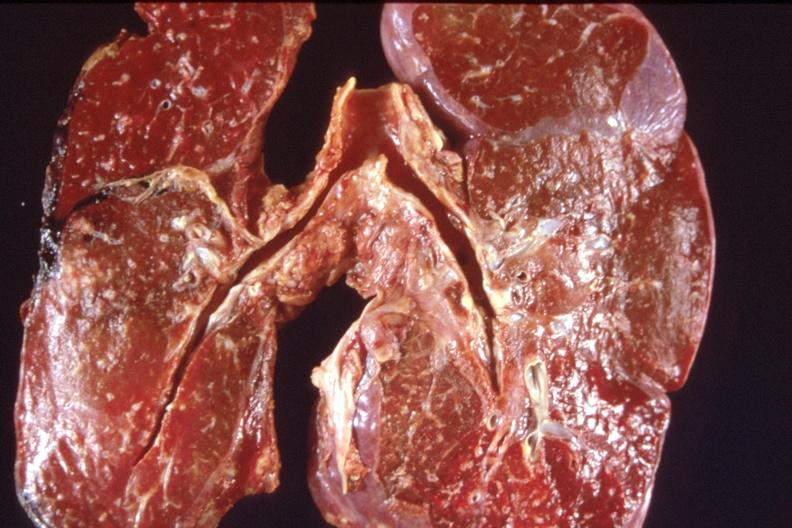s glial nodule present?
Answer the question using a single word or phrase. No 